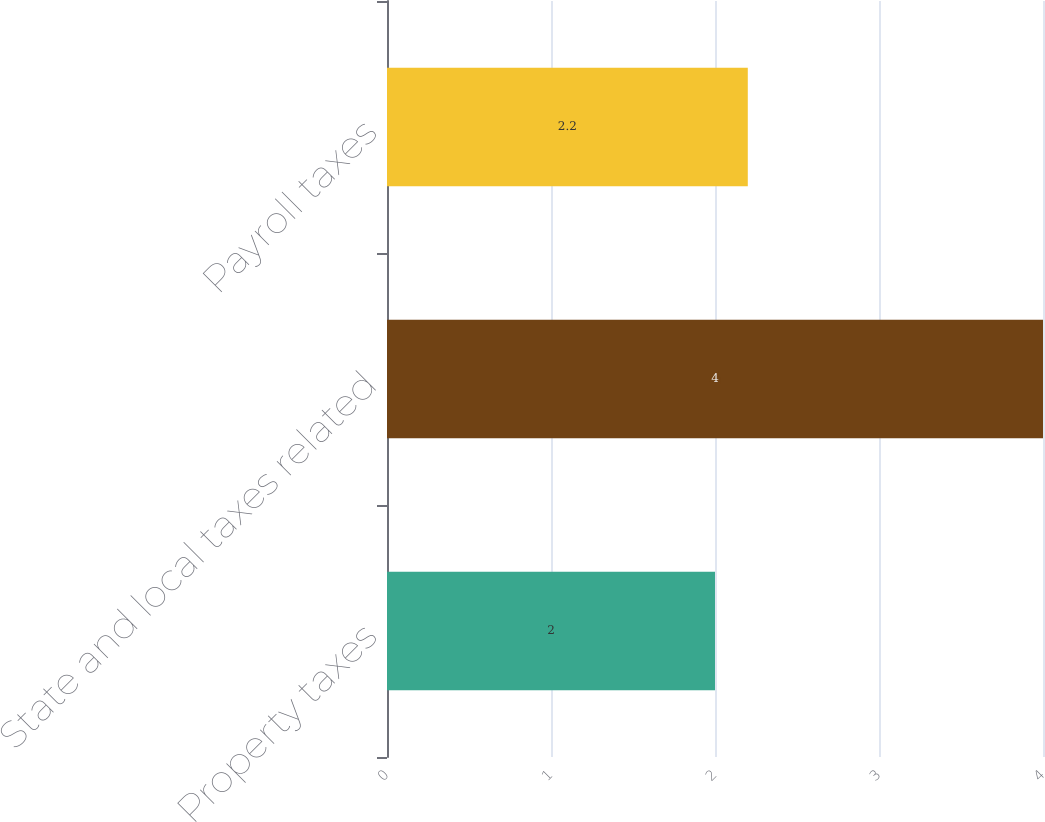<chart> <loc_0><loc_0><loc_500><loc_500><bar_chart><fcel>Property taxes<fcel>State and local taxes related<fcel>Payroll taxes<nl><fcel>2<fcel>4<fcel>2.2<nl></chart> 